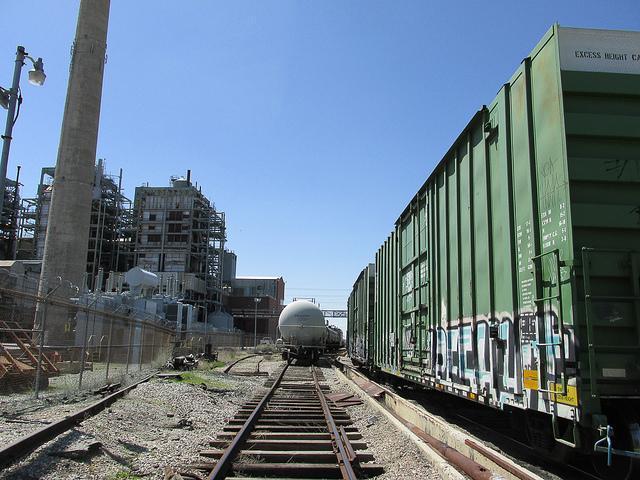How many trains are in the photo?
Give a very brief answer. 2. 